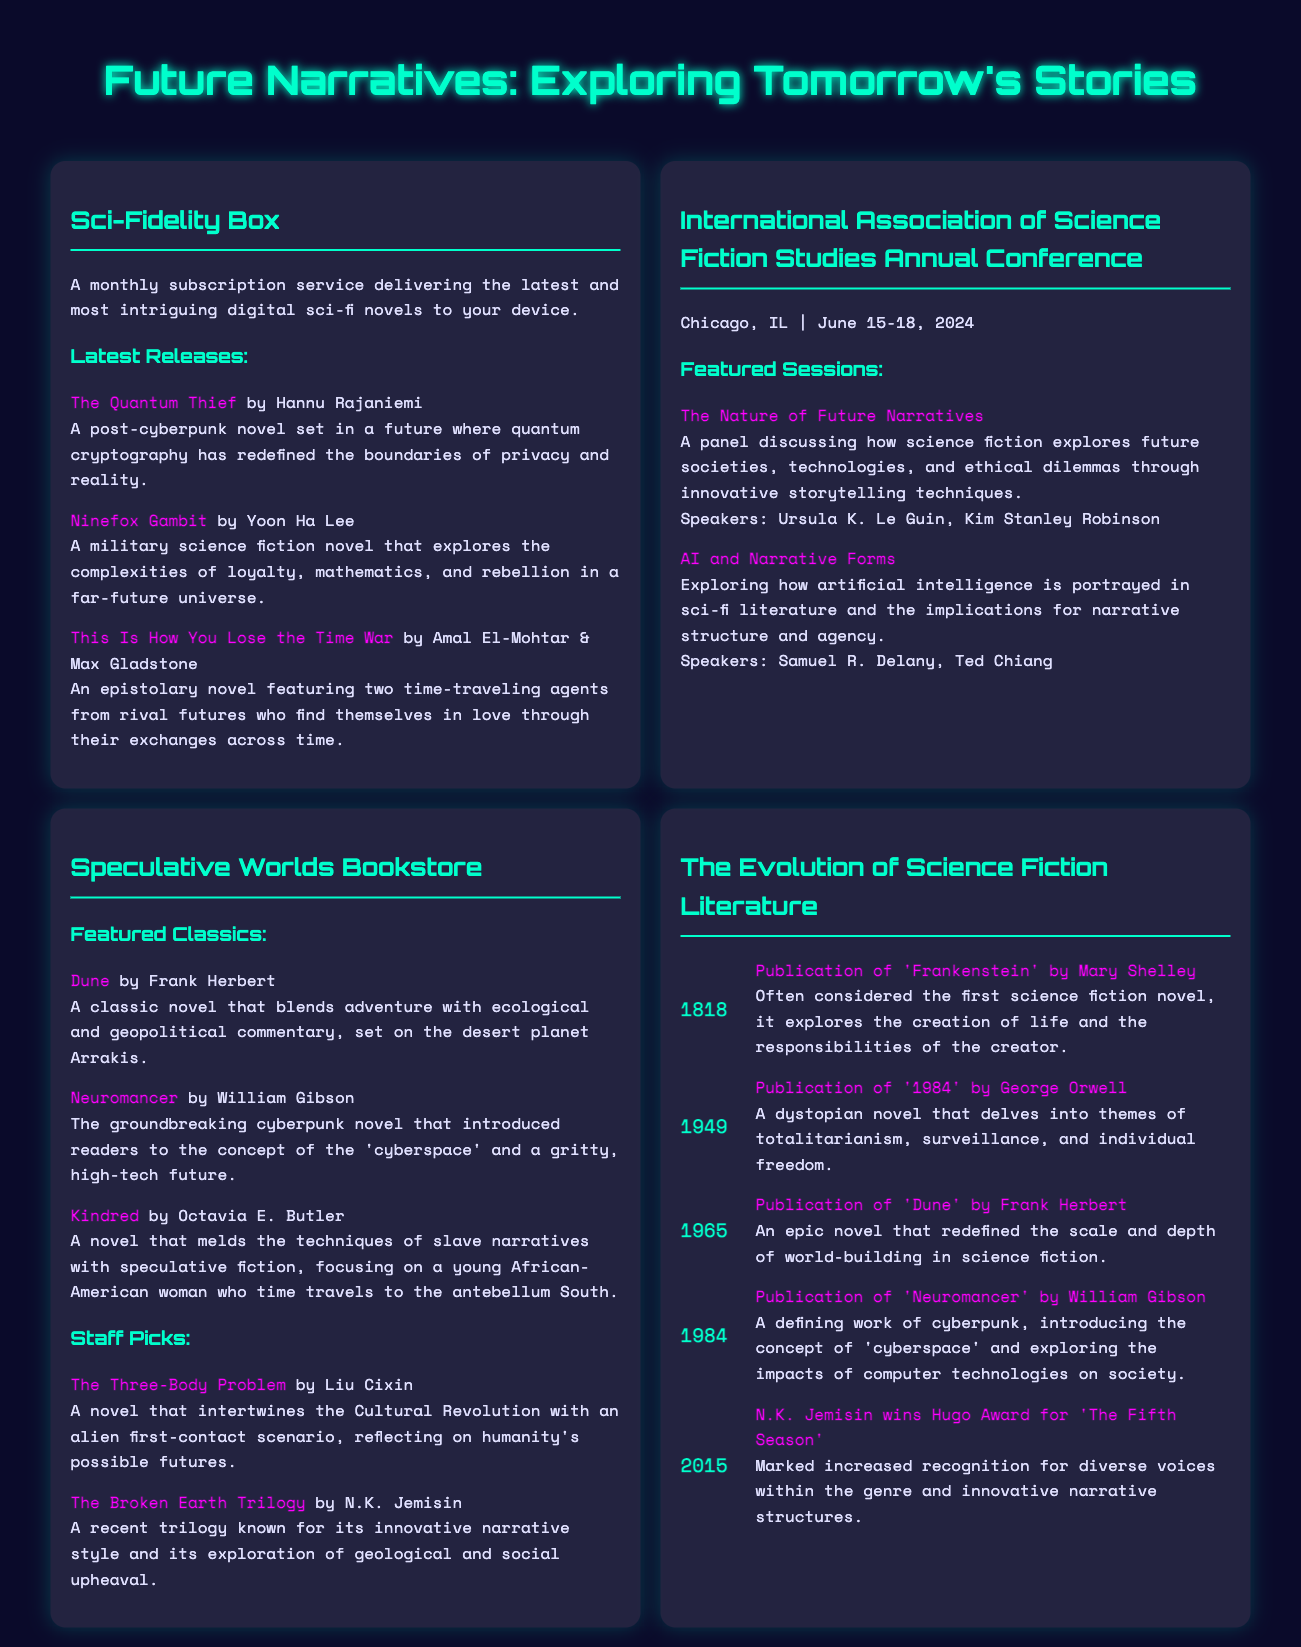What is the title of the magazine issue? The title of the magazine issue is stated prominently at the top of the document, "Future Narratives: Exploring Tomorrow's Stories."
Answer: Future Narratives: Exploring Tomorrow's Stories Who is the author of "The Quantum Thief"? The author of "The Quantum Thief" is mentioned in the list of latest releases under the Sci-Fidelity Box section.
Answer: Hannu Rajaniemi What year does the International Association of Science Fiction Studies Annual Conference take place? The year of the conference is given in the location and date information in the section about the conference.
Answer: 2024 How many featured sessions are listed for the conference? The number of featured sessions can be counted from the items listed under the Featured Sessions subsection in the conference section.
Answer: 2 Which novel is associated with N.K. Jemisin? N.K. Jemisin is mentioned in the context of winning the Hugo Award for her work, which is listed in the timeline of significant publications.
Answer: The Fifth Season What is the central theme of the panel titled "The Nature of Future Narratives"? The theme is summarized in the description following the panel title, indicating the focus of the discussion.
Answer: Future societies, technologies, and ethical dilemmas What does the Interactive Timeline section highlight? The section specifically lists significant milestones and influential works in science fiction literature, as indicated in the document's title.
Answer: Key milestones and influential works 